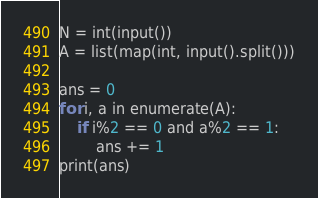<code> <loc_0><loc_0><loc_500><loc_500><_Python_>N = int(input())
A = list(map(int, input().split()))

ans = 0
for i, a in enumerate(A):
    if i%2 == 0 and a%2 == 1:
        ans += 1
print(ans)</code> 